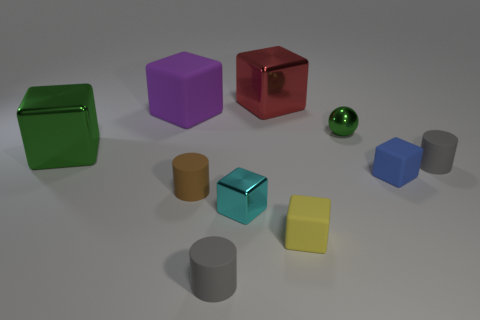Is there anything else that is the same shape as the purple object?
Provide a short and direct response. Yes. What color is the big rubber object that is the same shape as the small cyan metal thing?
Offer a terse response. Purple. What number of things are either yellow rubber things or tiny cylinders that are on the left side of the small metal sphere?
Provide a succinct answer. 3. Are there fewer tiny cylinders to the left of the cyan thing than rubber objects?
Your response must be concise. Yes. There is a green metallic block behind the gray cylinder left of the small cylinder right of the blue matte cube; how big is it?
Ensure brevity in your answer.  Large. What color is the cube that is right of the cyan block and on the left side of the tiny yellow block?
Keep it short and to the point. Red. What number of metallic things are there?
Your answer should be compact. 4. Is there any other thing that is the same size as the yellow thing?
Your response must be concise. Yes. Does the blue thing have the same material as the tiny yellow block?
Provide a short and direct response. Yes. Do the gray object that is in front of the blue cube and the metallic block behind the large purple cube have the same size?
Give a very brief answer. No. 